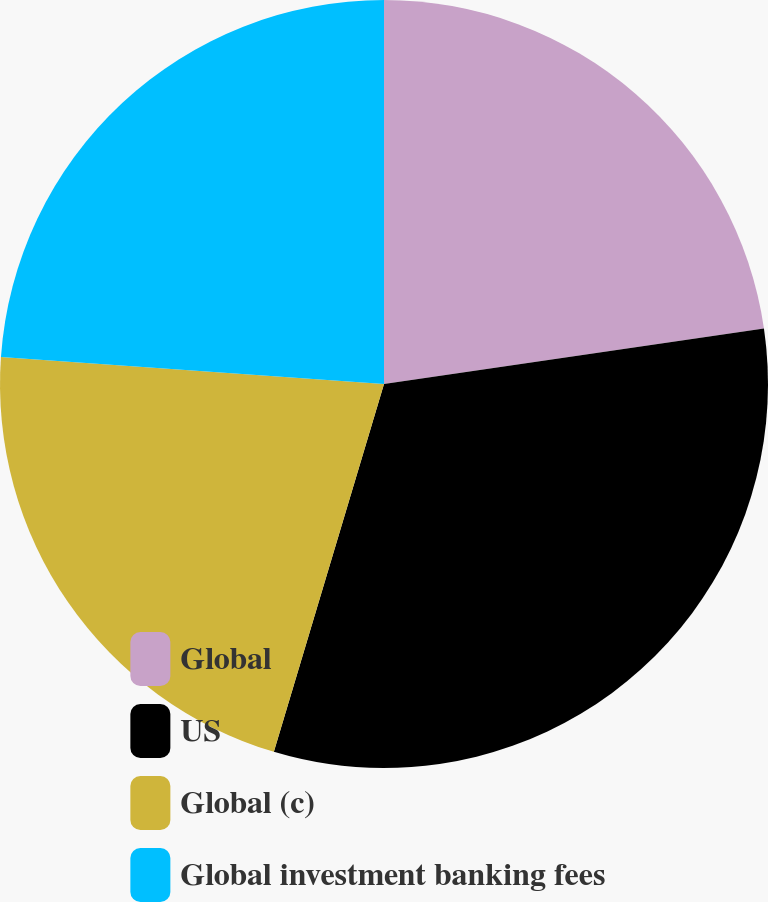<chart> <loc_0><loc_0><loc_500><loc_500><pie_chart><fcel>Global<fcel>US<fcel>Global (c)<fcel>Global investment banking fees<nl><fcel>22.69%<fcel>31.94%<fcel>21.49%<fcel>23.88%<nl></chart> 